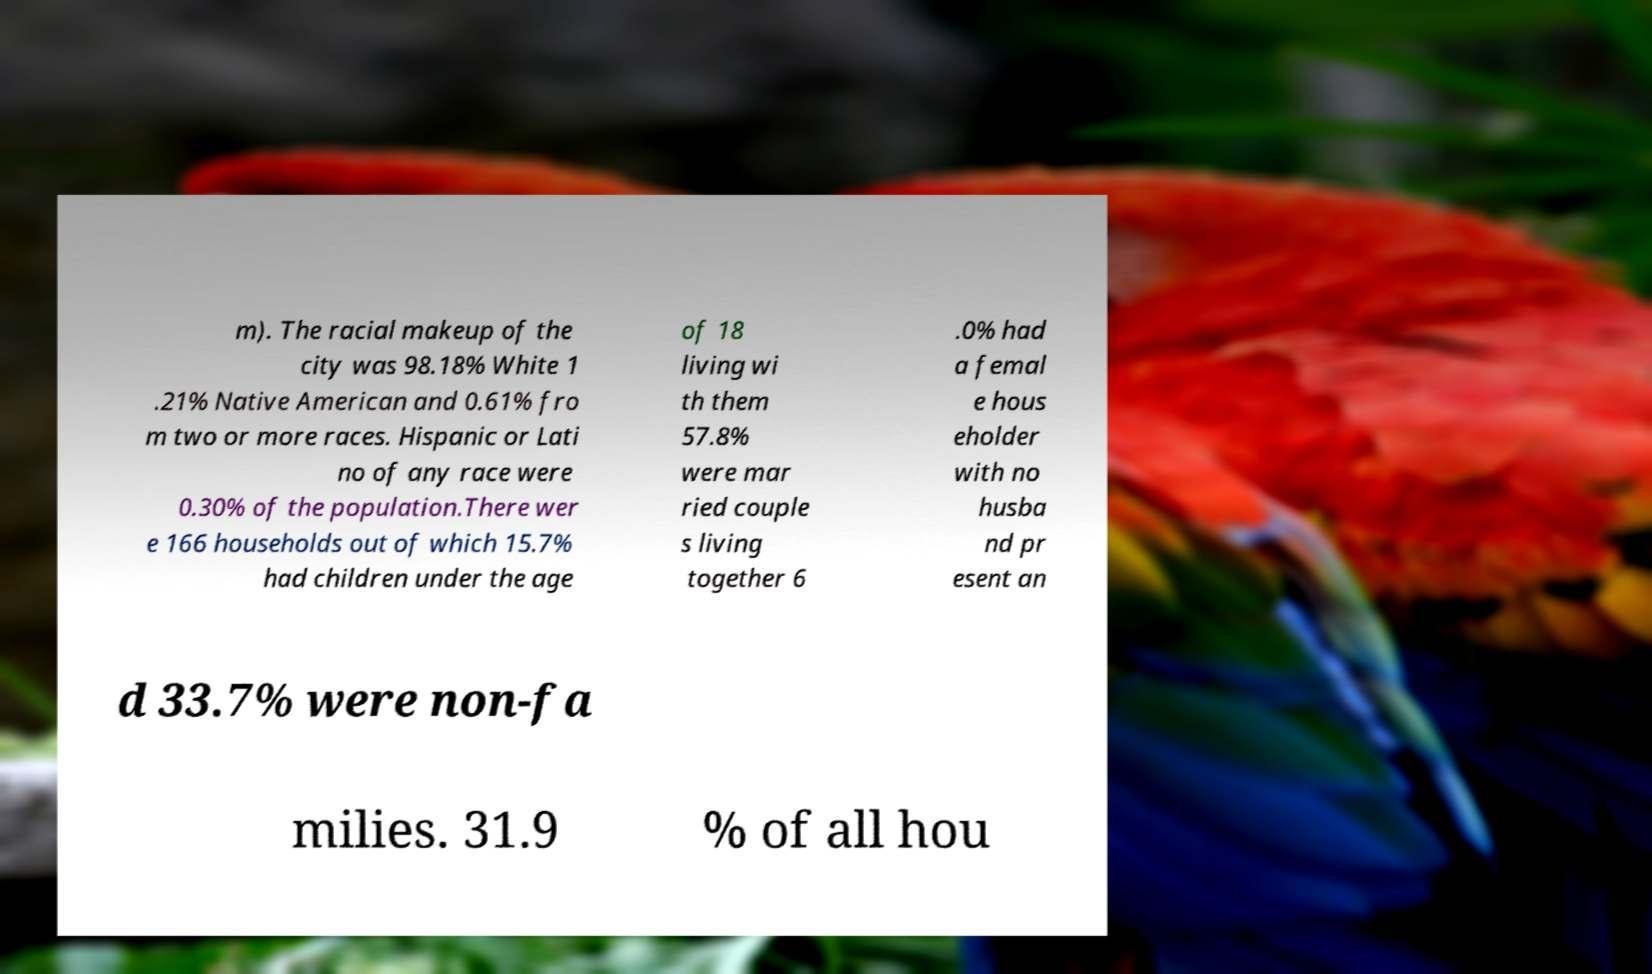What messages or text are displayed in this image? I need them in a readable, typed format. m). The racial makeup of the city was 98.18% White 1 .21% Native American and 0.61% fro m two or more races. Hispanic or Lati no of any race were 0.30% of the population.There wer e 166 households out of which 15.7% had children under the age of 18 living wi th them 57.8% were mar ried couple s living together 6 .0% had a femal e hous eholder with no husba nd pr esent an d 33.7% were non-fa milies. 31.9 % of all hou 